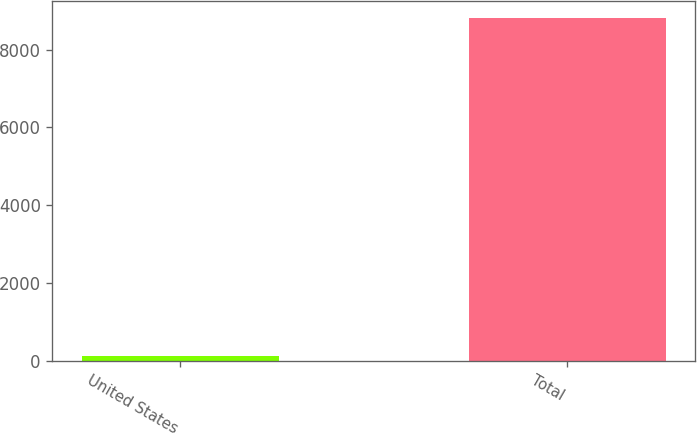Convert chart. <chart><loc_0><loc_0><loc_500><loc_500><bar_chart><fcel>United States<fcel>Total<nl><fcel>119<fcel>8811<nl></chart> 